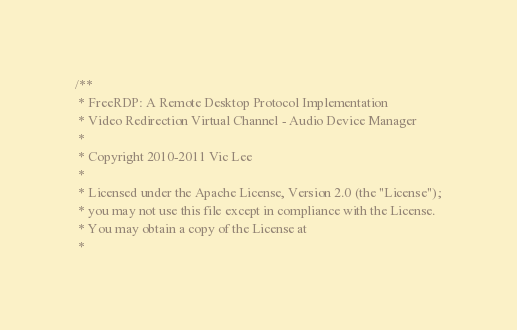Convert code to text. <code><loc_0><loc_0><loc_500><loc_500><_C_>/**
 * FreeRDP: A Remote Desktop Protocol Implementation
 * Video Redirection Virtual Channel - Audio Device Manager
 *
 * Copyright 2010-2011 Vic Lee
 *
 * Licensed under the Apache License, Version 2.0 (the "License");
 * you may not use this file except in compliance with the License.
 * You may obtain a copy of the License at
 *</code> 